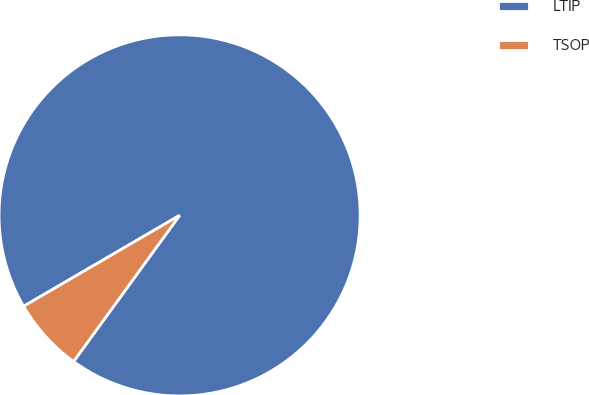<chart> <loc_0><loc_0><loc_500><loc_500><pie_chart><fcel>LTIP<fcel>TSOP<nl><fcel>93.39%<fcel>6.61%<nl></chart> 